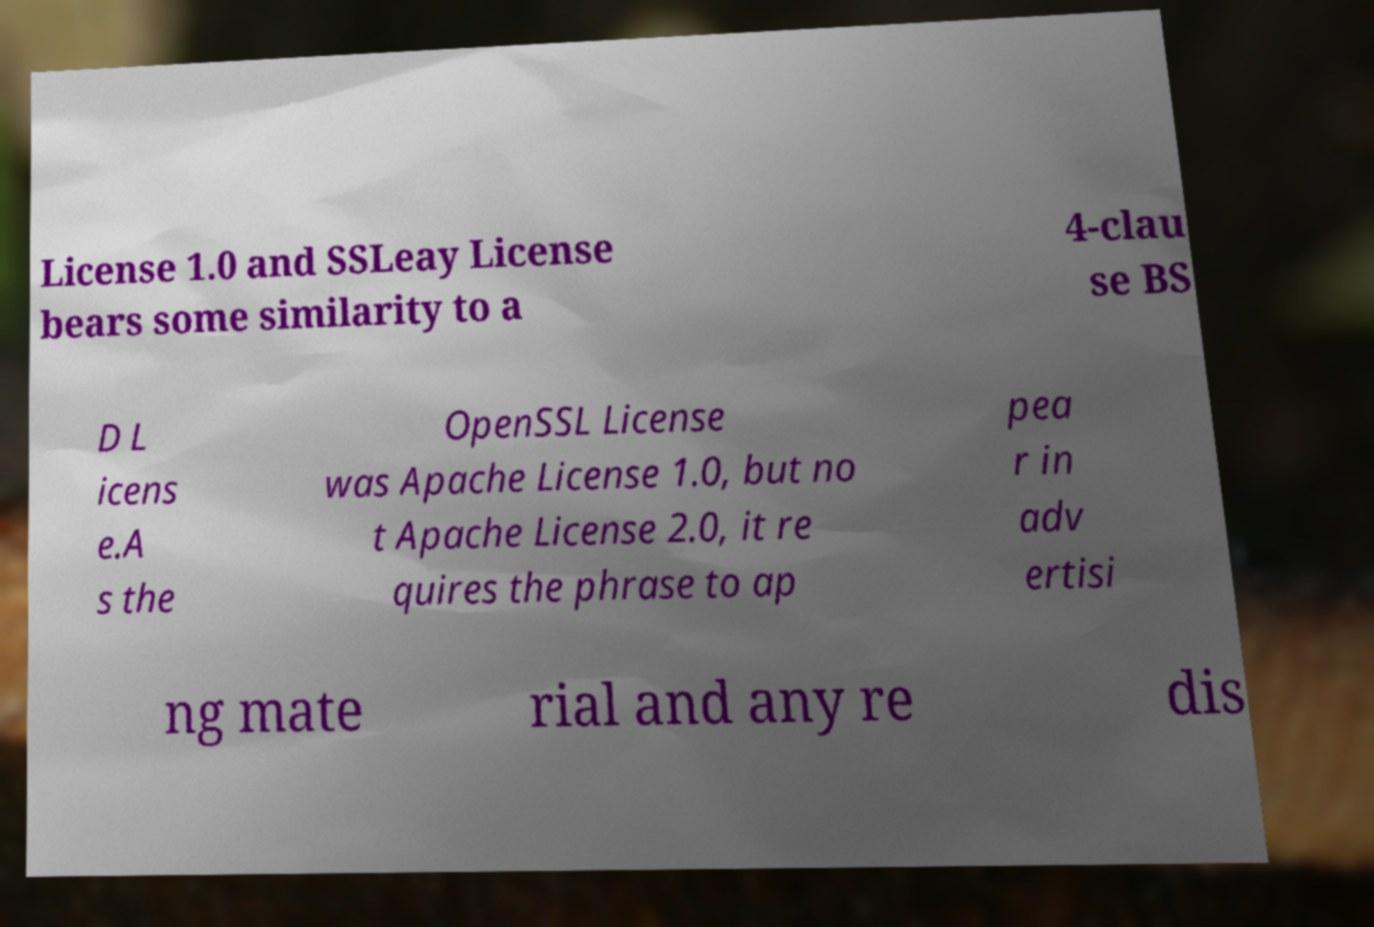Can you read and provide the text displayed in the image?This photo seems to have some interesting text. Can you extract and type it out for me? License 1.0 and SSLeay License bears some similarity to a 4-clau se BS D L icens e.A s the OpenSSL License was Apache License 1.0, but no t Apache License 2.0, it re quires the phrase to ap pea r in adv ertisi ng mate rial and any re dis 